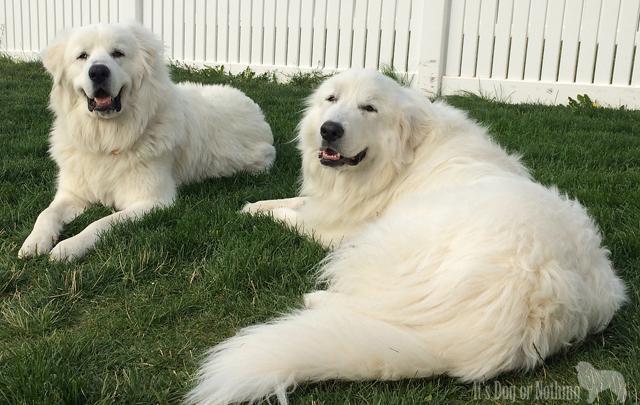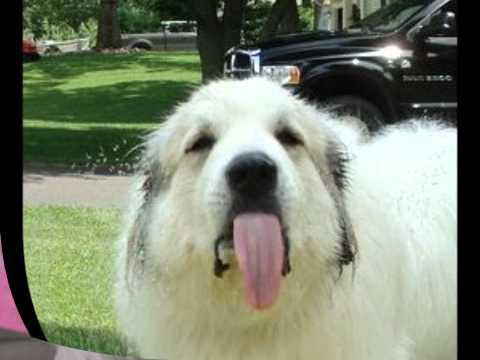The first image is the image on the left, the second image is the image on the right. For the images shown, is this caption "There are more than two dogs" true? Answer yes or no. Yes. The first image is the image on the left, the second image is the image on the right. Examine the images to the left and right. Is the description "There are three dogs." accurate? Answer yes or no. Yes. 